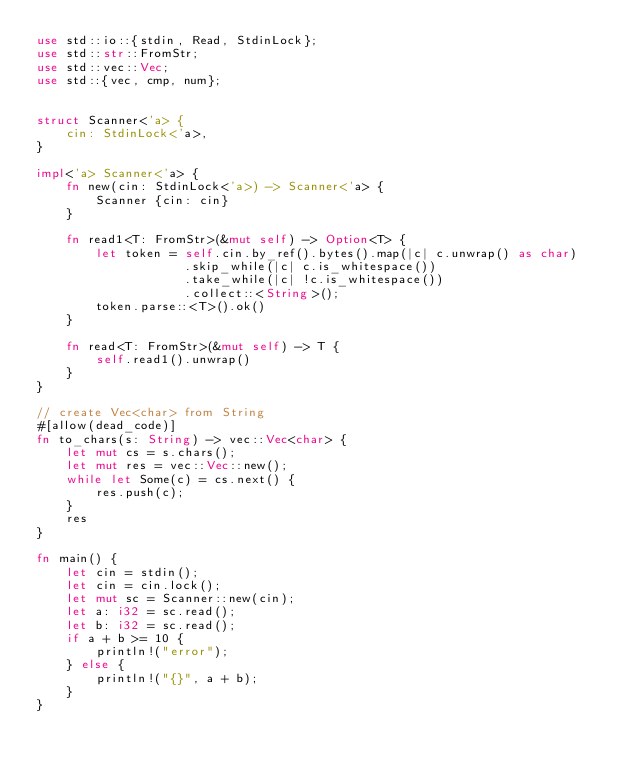Convert code to text. <code><loc_0><loc_0><loc_500><loc_500><_Rust_>use std::io::{stdin, Read, StdinLock};
use std::str::FromStr;
use std::vec::Vec;
use std::{vec, cmp, num};


struct Scanner<'a> {
    cin: StdinLock<'a>,
}

impl<'a> Scanner<'a> {
    fn new(cin: StdinLock<'a>) -> Scanner<'a> {
        Scanner {cin: cin}
    }

    fn read1<T: FromStr>(&mut self) -> Option<T> {
        let token = self.cin.by_ref().bytes().map(|c| c.unwrap() as char)
                    .skip_while(|c| c.is_whitespace())
                    .take_while(|c| !c.is_whitespace())
                    .collect::<String>();
        token.parse::<T>().ok()
    }

    fn read<T: FromStr>(&mut self) -> T {
        self.read1().unwrap()
    }
}

// create Vec<char> from String
#[allow(dead_code)]
fn to_chars(s: String) -> vec::Vec<char> {
    let mut cs = s.chars();
    let mut res = vec::Vec::new();
    while let Some(c) = cs.next() {
        res.push(c);
    }
    res
}

fn main() {
    let cin = stdin();
    let cin = cin.lock();
    let mut sc = Scanner::new(cin);
    let a: i32 = sc.read();
    let b: i32 = sc.read();
    if a + b >= 10 {
        println!("error");
    } else {
        println!("{}", a + b);
    }
}</code> 